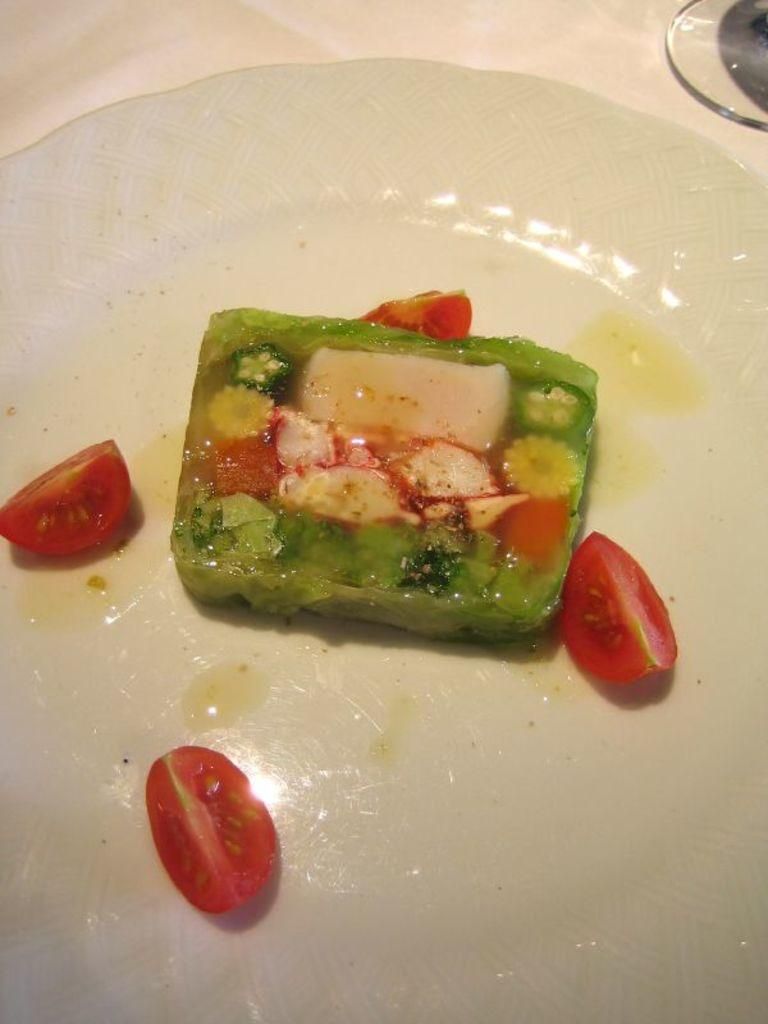What is on the plate that is visible in the image? There is a plate with food in the image. Can you describe the object that is present in the image? Unfortunately, the provided facts do not give any details about the object in the image. What is the weight of the beam in the image? There is no beam present in the image, so it is not possible to determine its weight. 